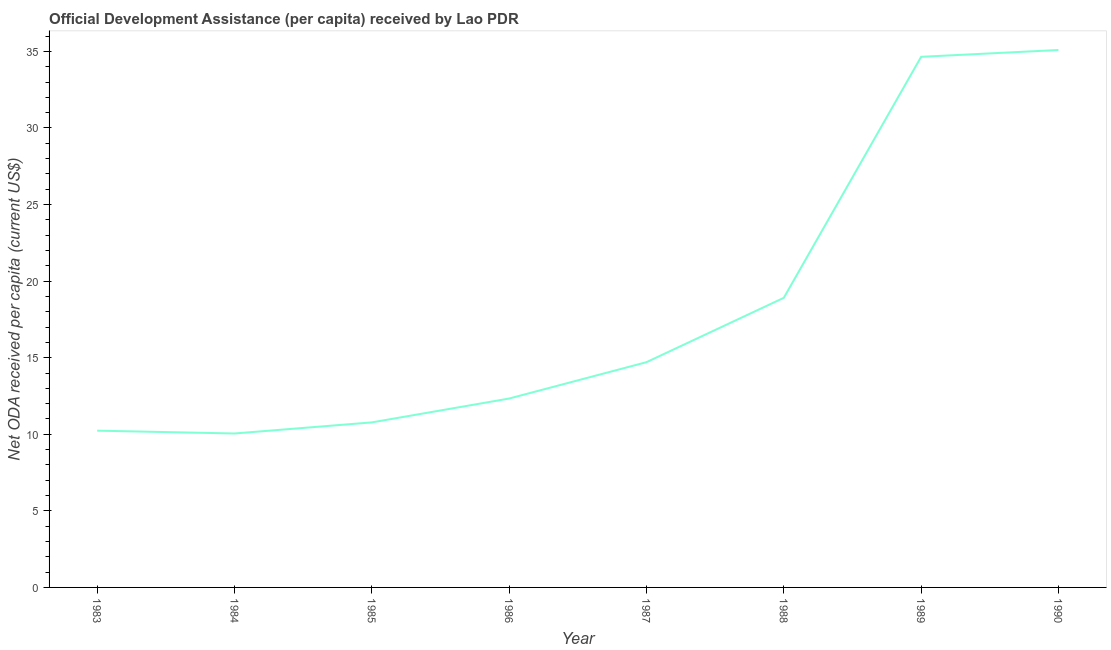What is the net oda received per capita in 1984?
Offer a terse response. 10.05. Across all years, what is the maximum net oda received per capita?
Keep it short and to the point. 35.09. Across all years, what is the minimum net oda received per capita?
Ensure brevity in your answer.  10.05. In which year was the net oda received per capita maximum?
Keep it short and to the point. 1990. What is the sum of the net oda received per capita?
Ensure brevity in your answer.  146.76. What is the difference between the net oda received per capita in 1983 and 1985?
Give a very brief answer. -0.54. What is the average net oda received per capita per year?
Provide a short and direct response. 18.35. What is the median net oda received per capita?
Provide a succinct answer. 13.52. In how many years, is the net oda received per capita greater than 32 US$?
Offer a very short reply. 2. Do a majority of the years between 1987 and 1985 (inclusive) have net oda received per capita greater than 33 US$?
Make the answer very short. No. What is the ratio of the net oda received per capita in 1986 to that in 1990?
Provide a short and direct response. 0.35. Is the difference between the net oda received per capita in 1984 and 1989 greater than the difference between any two years?
Keep it short and to the point. No. What is the difference between the highest and the second highest net oda received per capita?
Give a very brief answer. 0.45. Is the sum of the net oda received per capita in 1984 and 1990 greater than the maximum net oda received per capita across all years?
Give a very brief answer. Yes. What is the difference between the highest and the lowest net oda received per capita?
Ensure brevity in your answer.  25.04. Does the net oda received per capita monotonically increase over the years?
Your answer should be compact. No. How many years are there in the graph?
Keep it short and to the point. 8. What is the difference between two consecutive major ticks on the Y-axis?
Give a very brief answer. 5. Are the values on the major ticks of Y-axis written in scientific E-notation?
Provide a short and direct response. No. Does the graph contain any zero values?
Offer a terse response. No. Does the graph contain grids?
Provide a succinct answer. No. What is the title of the graph?
Your answer should be very brief. Official Development Assistance (per capita) received by Lao PDR. What is the label or title of the Y-axis?
Your answer should be compact. Net ODA received per capita (current US$). What is the Net ODA received per capita (current US$) of 1983?
Keep it short and to the point. 10.24. What is the Net ODA received per capita (current US$) in 1984?
Your response must be concise. 10.05. What is the Net ODA received per capita (current US$) in 1985?
Ensure brevity in your answer.  10.78. What is the Net ODA received per capita (current US$) of 1986?
Your answer should be compact. 12.33. What is the Net ODA received per capita (current US$) of 1987?
Ensure brevity in your answer.  14.71. What is the Net ODA received per capita (current US$) of 1988?
Ensure brevity in your answer.  18.91. What is the Net ODA received per capita (current US$) of 1989?
Provide a short and direct response. 34.65. What is the Net ODA received per capita (current US$) in 1990?
Your response must be concise. 35.09. What is the difference between the Net ODA received per capita (current US$) in 1983 and 1984?
Your answer should be very brief. 0.18. What is the difference between the Net ODA received per capita (current US$) in 1983 and 1985?
Ensure brevity in your answer.  -0.54. What is the difference between the Net ODA received per capita (current US$) in 1983 and 1986?
Offer a terse response. -2.1. What is the difference between the Net ODA received per capita (current US$) in 1983 and 1987?
Your answer should be very brief. -4.47. What is the difference between the Net ODA received per capita (current US$) in 1983 and 1988?
Offer a terse response. -8.68. What is the difference between the Net ODA received per capita (current US$) in 1983 and 1989?
Your answer should be very brief. -24.41. What is the difference between the Net ODA received per capita (current US$) in 1983 and 1990?
Provide a succinct answer. -24.86. What is the difference between the Net ODA received per capita (current US$) in 1984 and 1985?
Offer a terse response. -0.72. What is the difference between the Net ODA received per capita (current US$) in 1984 and 1986?
Offer a very short reply. -2.28. What is the difference between the Net ODA received per capita (current US$) in 1984 and 1987?
Give a very brief answer. -4.66. What is the difference between the Net ODA received per capita (current US$) in 1984 and 1988?
Your response must be concise. -8.86. What is the difference between the Net ODA received per capita (current US$) in 1984 and 1989?
Make the answer very short. -24.6. What is the difference between the Net ODA received per capita (current US$) in 1984 and 1990?
Make the answer very short. -25.04. What is the difference between the Net ODA received per capita (current US$) in 1985 and 1986?
Provide a succinct answer. -1.56. What is the difference between the Net ODA received per capita (current US$) in 1985 and 1987?
Your response must be concise. -3.93. What is the difference between the Net ODA received per capita (current US$) in 1985 and 1988?
Make the answer very short. -8.14. What is the difference between the Net ODA received per capita (current US$) in 1985 and 1989?
Provide a short and direct response. -23.87. What is the difference between the Net ODA received per capita (current US$) in 1985 and 1990?
Your answer should be compact. -24.32. What is the difference between the Net ODA received per capita (current US$) in 1986 and 1987?
Provide a short and direct response. -2.37. What is the difference between the Net ODA received per capita (current US$) in 1986 and 1988?
Offer a terse response. -6.58. What is the difference between the Net ODA received per capita (current US$) in 1986 and 1989?
Provide a short and direct response. -22.31. What is the difference between the Net ODA received per capita (current US$) in 1986 and 1990?
Ensure brevity in your answer.  -22.76. What is the difference between the Net ODA received per capita (current US$) in 1987 and 1988?
Provide a short and direct response. -4.2. What is the difference between the Net ODA received per capita (current US$) in 1987 and 1989?
Provide a short and direct response. -19.94. What is the difference between the Net ODA received per capita (current US$) in 1987 and 1990?
Your answer should be compact. -20.38. What is the difference between the Net ODA received per capita (current US$) in 1988 and 1989?
Make the answer very short. -15.74. What is the difference between the Net ODA received per capita (current US$) in 1988 and 1990?
Offer a terse response. -16.18. What is the difference between the Net ODA received per capita (current US$) in 1989 and 1990?
Your answer should be compact. -0.45. What is the ratio of the Net ODA received per capita (current US$) in 1983 to that in 1986?
Ensure brevity in your answer.  0.83. What is the ratio of the Net ODA received per capita (current US$) in 1983 to that in 1987?
Offer a very short reply. 0.7. What is the ratio of the Net ODA received per capita (current US$) in 1983 to that in 1988?
Give a very brief answer. 0.54. What is the ratio of the Net ODA received per capita (current US$) in 1983 to that in 1989?
Your answer should be very brief. 0.29. What is the ratio of the Net ODA received per capita (current US$) in 1983 to that in 1990?
Keep it short and to the point. 0.29. What is the ratio of the Net ODA received per capita (current US$) in 1984 to that in 1985?
Your response must be concise. 0.93. What is the ratio of the Net ODA received per capita (current US$) in 1984 to that in 1986?
Provide a succinct answer. 0.81. What is the ratio of the Net ODA received per capita (current US$) in 1984 to that in 1987?
Your answer should be very brief. 0.68. What is the ratio of the Net ODA received per capita (current US$) in 1984 to that in 1988?
Provide a succinct answer. 0.53. What is the ratio of the Net ODA received per capita (current US$) in 1984 to that in 1989?
Your answer should be very brief. 0.29. What is the ratio of the Net ODA received per capita (current US$) in 1984 to that in 1990?
Keep it short and to the point. 0.29. What is the ratio of the Net ODA received per capita (current US$) in 1985 to that in 1986?
Your answer should be very brief. 0.87. What is the ratio of the Net ODA received per capita (current US$) in 1985 to that in 1987?
Your answer should be very brief. 0.73. What is the ratio of the Net ODA received per capita (current US$) in 1985 to that in 1988?
Provide a short and direct response. 0.57. What is the ratio of the Net ODA received per capita (current US$) in 1985 to that in 1989?
Provide a succinct answer. 0.31. What is the ratio of the Net ODA received per capita (current US$) in 1985 to that in 1990?
Keep it short and to the point. 0.31. What is the ratio of the Net ODA received per capita (current US$) in 1986 to that in 1987?
Offer a terse response. 0.84. What is the ratio of the Net ODA received per capita (current US$) in 1986 to that in 1988?
Keep it short and to the point. 0.65. What is the ratio of the Net ODA received per capita (current US$) in 1986 to that in 1989?
Offer a terse response. 0.36. What is the ratio of the Net ODA received per capita (current US$) in 1986 to that in 1990?
Give a very brief answer. 0.35. What is the ratio of the Net ODA received per capita (current US$) in 1987 to that in 1988?
Make the answer very short. 0.78. What is the ratio of the Net ODA received per capita (current US$) in 1987 to that in 1989?
Ensure brevity in your answer.  0.42. What is the ratio of the Net ODA received per capita (current US$) in 1987 to that in 1990?
Your answer should be compact. 0.42. What is the ratio of the Net ODA received per capita (current US$) in 1988 to that in 1989?
Give a very brief answer. 0.55. What is the ratio of the Net ODA received per capita (current US$) in 1988 to that in 1990?
Offer a terse response. 0.54. What is the ratio of the Net ODA received per capita (current US$) in 1989 to that in 1990?
Your answer should be very brief. 0.99. 